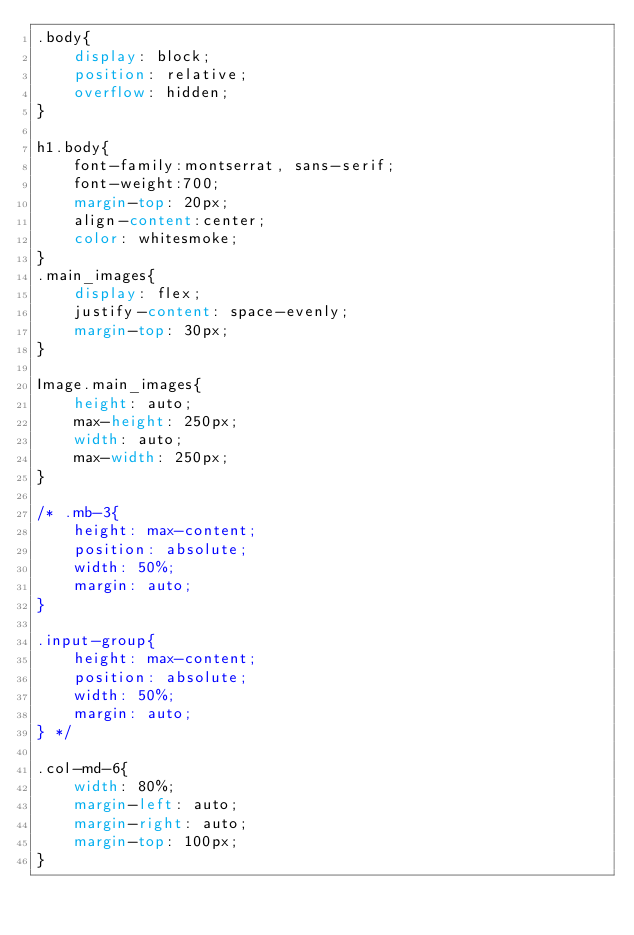<code> <loc_0><loc_0><loc_500><loc_500><_CSS_>.body{
    display: block;
    position: relative;
    overflow: hidden;
}

h1.body{
    font-family:montserrat, sans-serif;
    font-weight:700;
    margin-top: 20px;
    align-content:center;
    color: whitesmoke;
}
.main_images{
    display: flex;
    justify-content: space-evenly;
    margin-top: 30px;
}

Image.main_images{
    height: auto;
    max-height: 250px;
    width: auto;
    max-width: 250px;
}

/* .mb-3{
    height: max-content;
    position: absolute;
    width: 50%;
    margin: auto;
}

.input-group{
    height: max-content;
    position: absolute;
    width: 50%;
    margin: auto;
} */

.col-md-6{
    width: 80%;
    margin-left: auto;
    margin-right: auto;
    margin-top: 100px;
}</code> 